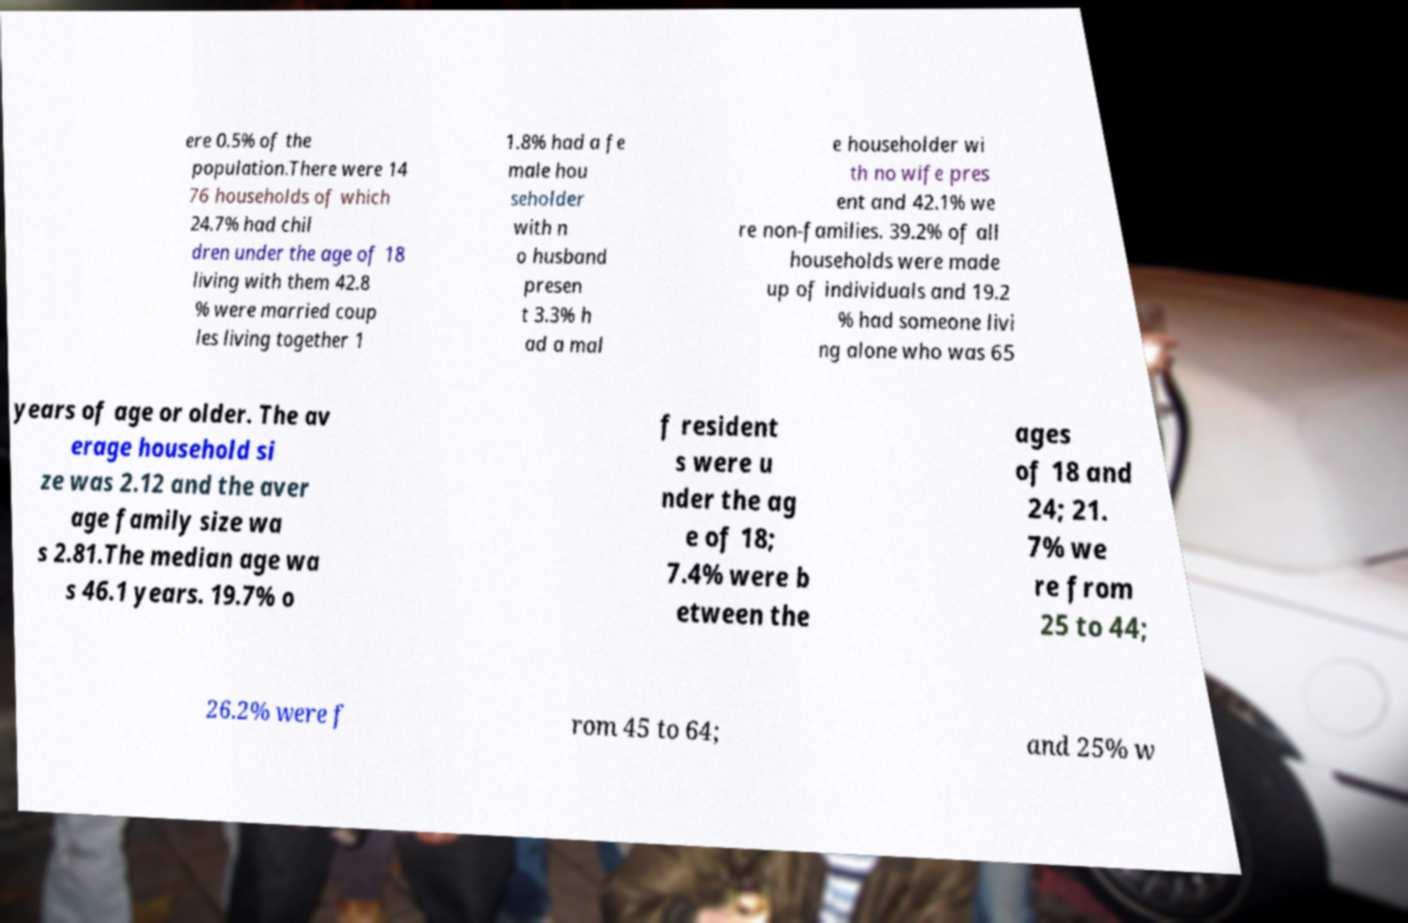For documentation purposes, I need the text within this image transcribed. Could you provide that? ere 0.5% of the population.There were 14 76 households of which 24.7% had chil dren under the age of 18 living with them 42.8 % were married coup les living together 1 1.8% had a fe male hou seholder with n o husband presen t 3.3% h ad a mal e householder wi th no wife pres ent and 42.1% we re non-families. 39.2% of all households were made up of individuals and 19.2 % had someone livi ng alone who was 65 years of age or older. The av erage household si ze was 2.12 and the aver age family size wa s 2.81.The median age wa s 46.1 years. 19.7% o f resident s were u nder the ag e of 18; 7.4% were b etween the ages of 18 and 24; 21. 7% we re from 25 to 44; 26.2% were f rom 45 to 64; and 25% w 